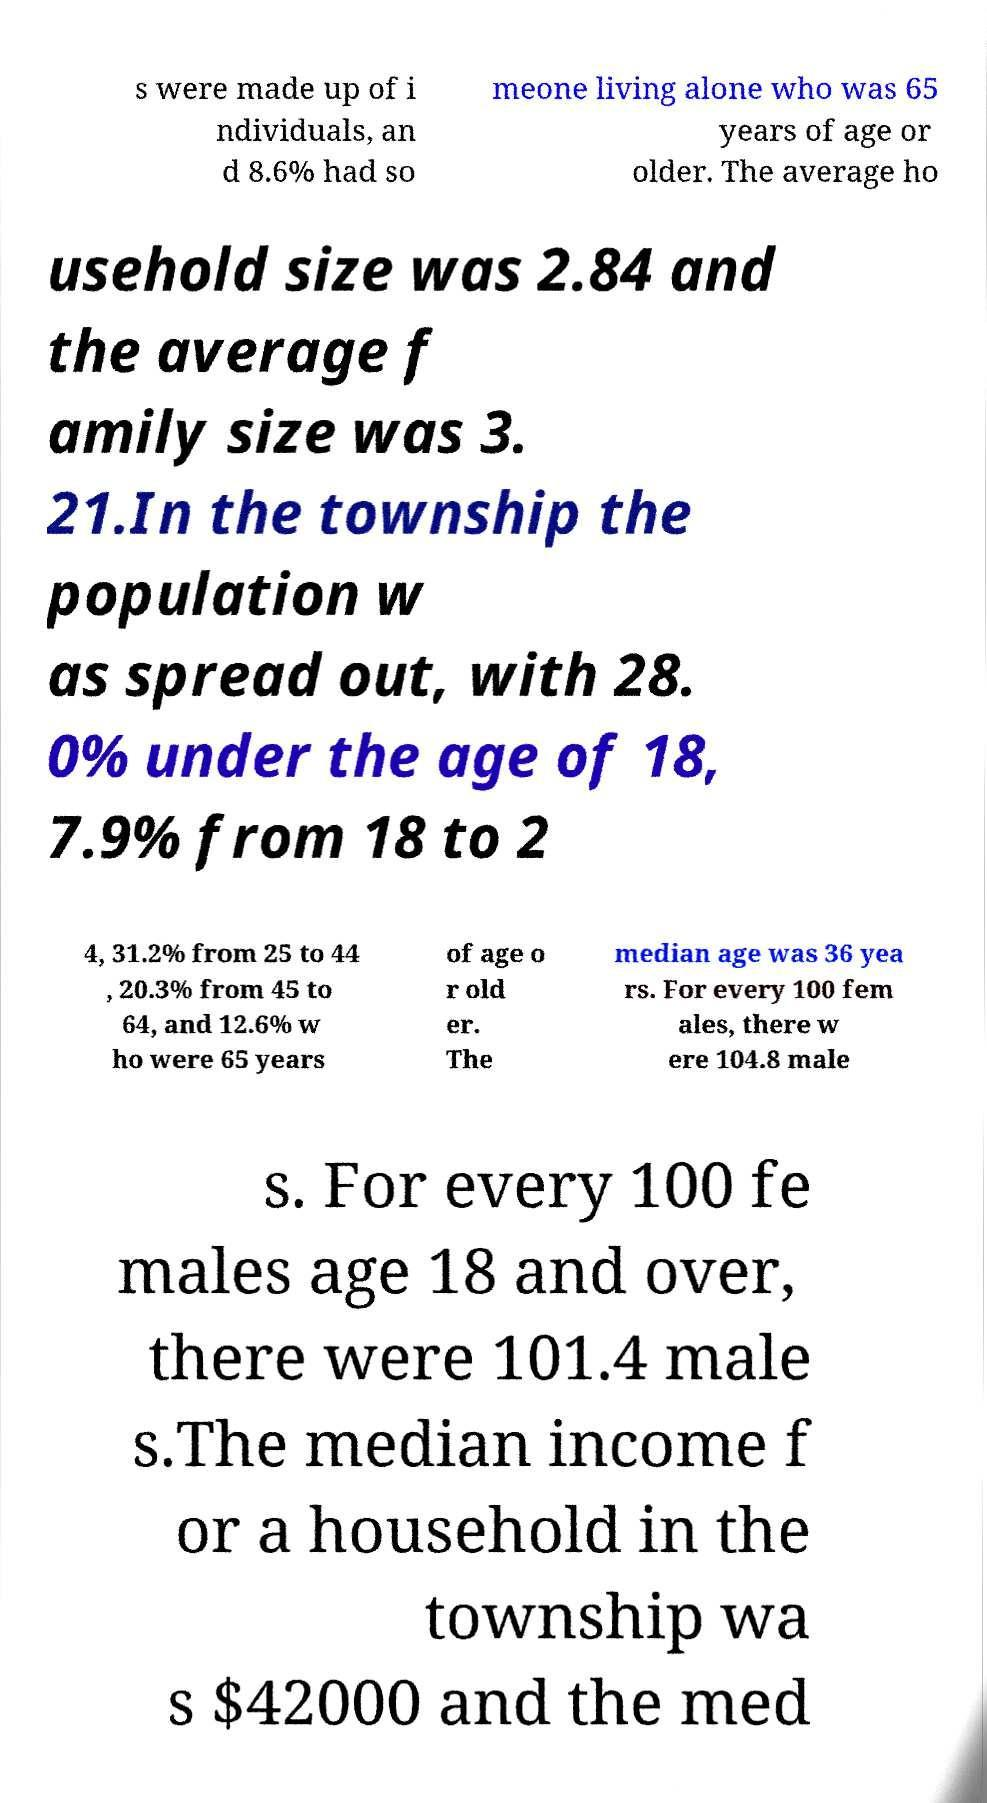I need the written content from this picture converted into text. Can you do that? s were made up of i ndividuals, an d 8.6% had so meone living alone who was 65 years of age or older. The average ho usehold size was 2.84 and the average f amily size was 3. 21.In the township the population w as spread out, with 28. 0% under the age of 18, 7.9% from 18 to 2 4, 31.2% from 25 to 44 , 20.3% from 45 to 64, and 12.6% w ho were 65 years of age o r old er. The median age was 36 yea rs. For every 100 fem ales, there w ere 104.8 male s. For every 100 fe males age 18 and over, there were 101.4 male s.The median income f or a household in the township wa s $42000 and the med 